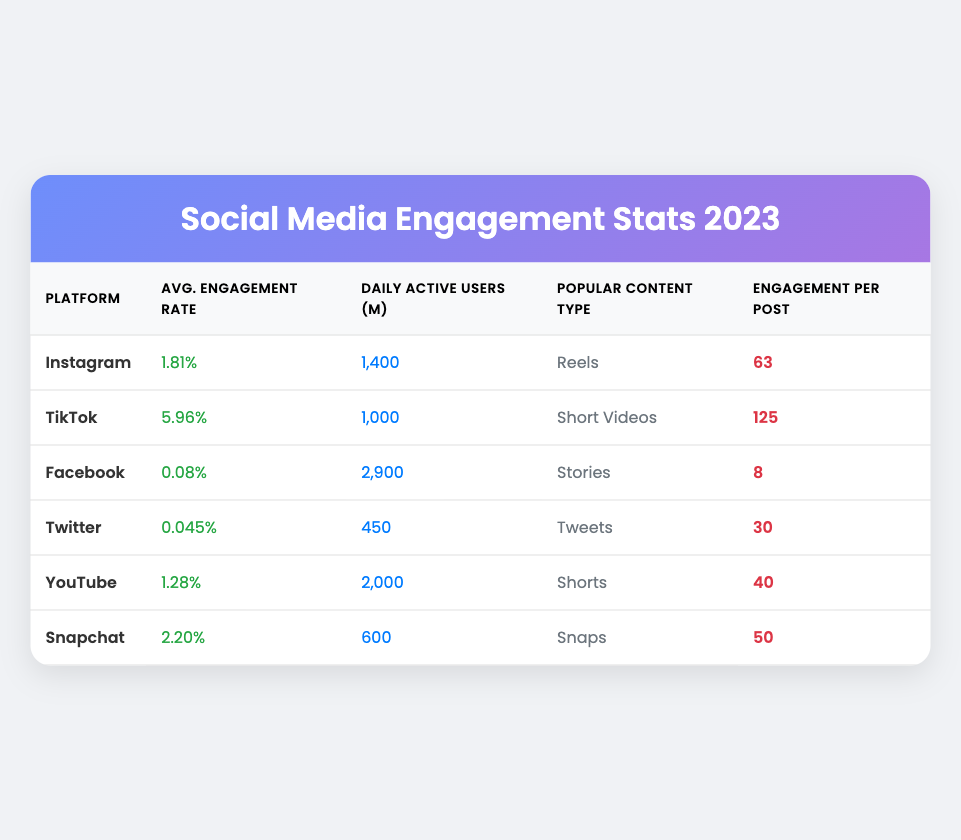What is the average engagement rate of Facebook? The table shows that Facebook has an average engagement rate of 0.08%.
Answer: 0.08% Which platform has the highest average engagement rate? According to the table, TikTok has the highest average engagement rate at 5.96%.
Answer: TikTok How many daily active users does Instagram have? The table indicates that Instagram has 1,400 million daily active users.
Answer: 1,400 million What is the engagement per post for Snapchat? From the table, Snapchat has an engagement per post of 50.
Answer: 50 Is the average engagement rate for YouTube higher than that of Twitter? Yes, YouTube has an engagement rate of 1.28%, while Twitter's rate is only 0.045%.
Answer: Yes What is the total number of daily active users across all platforms listed? To find the total, add the daily active users: 1400 + 1000 + 2900 + 450 + 2000 + 600 = 10,350 million.
Answer: 10,350 million What is the difference in engagement per post between TikTok and Facebook? TikTok's engagement per post is 125, and Facebook's is 8. The difference is 125 - 8 = 117.
Answer: 117 Which platform has a lower engagement rate, Instagram or YouTube? Instagram's engagement rate is 1.81%, and YouTube's is 1.28%. Since 1.28% is lower, YouTube has the lower engagement rate.
Answer: YouTube How many more daily active users does Facebook have compared to Snapchat? Facebook has 2,900 million users and Snapchat has 600 million. The difference is 2900 - 600 = 2,300 million.
Answer: 2,300 million 